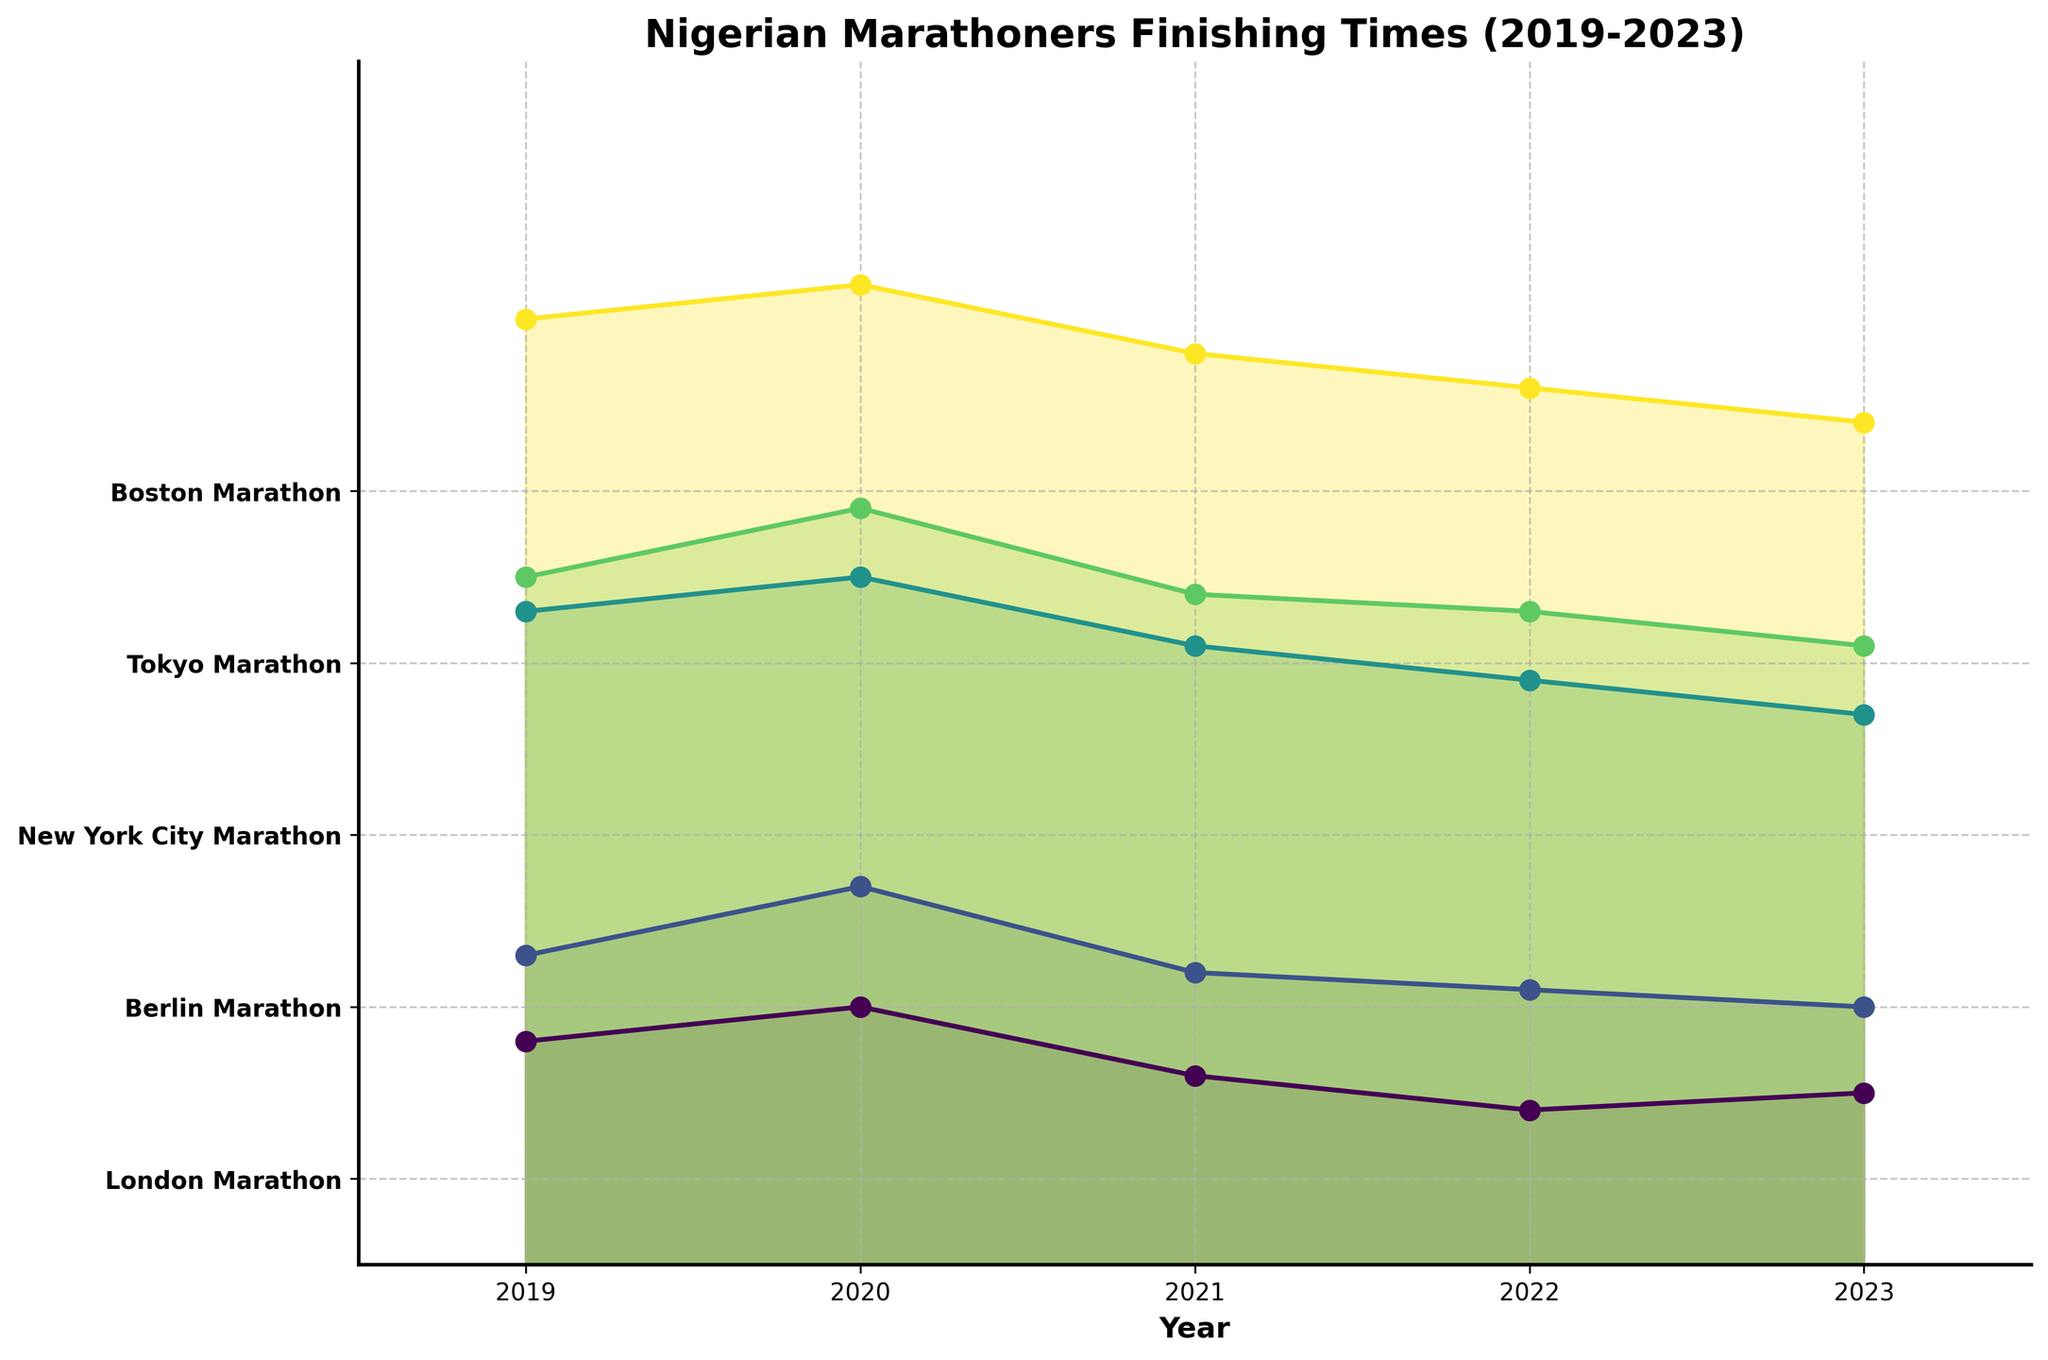What's the title of the plot? The title of the plot is displayed at the top of the figure. Simply read it.
Answer: Nigerian Marathoners Finishing Times (2019-2023) How many marathons are displayed in the plot? Count the number of unique y-tick labels on the left side of the figure. These represent different marathons.
Answer: 5 In which marathon and year did Nigerian marathoners achieve the fastest time? Look for the lowest point on the plot surface for each marathon. Cross-reference the time on the y-axis and the specific marathon/year on the x-axis.
Answer: Berlin Marathon, 2023 How does the 2023 finishing time of the New York City Marathon compare to the 2019 finishing time? Locate the points for New York City Marathon in 2019 and 2023, then compare the y-values (finishing times).
Answer: The 2023 time is faster than the 2019 time What trend can be observed for Nigerian marathoners in the Berlin Marathon from 2019 to 2023? Observe the general direction of the Berlin Marathon line from 2019 to 2023. Note if the finishing times are getting faster, slower, or remain constant.
Answer: The times generally improve (get faster) over the years Which marathon consistently shows the highest finishing times throughout the years? Identify which marathon line tends to stay at higher y-values across all years.
Answer: New York City Marathon What is the range of finishing times for the Tokyo Marathon from 2019 to 2023? Identify the highest and lowest points for the Tokyo Marathon, and calculate the difference.
Answer: 2.24 to 2.16, range = 0.08 Are there any ties in the finishing times between two or more marathons in a specific year? Look for any years where the lines for different marathons are at the same y-value.
Answer: No How does the 2022 finishing time of the Boston Marathon compare to the Tokyo Marathon in the same year? Locate the points for the Boston and Tokyo Marathons in 2022, then compare their y-values.
Answer: The Tokyo Marathon time is faster What is the median finishing time for Nigerian marathoners in the London Marathon from 2019 to 2023? List all the times for the London Marathon, order them, and find the middle value.
Answer: 2.21 